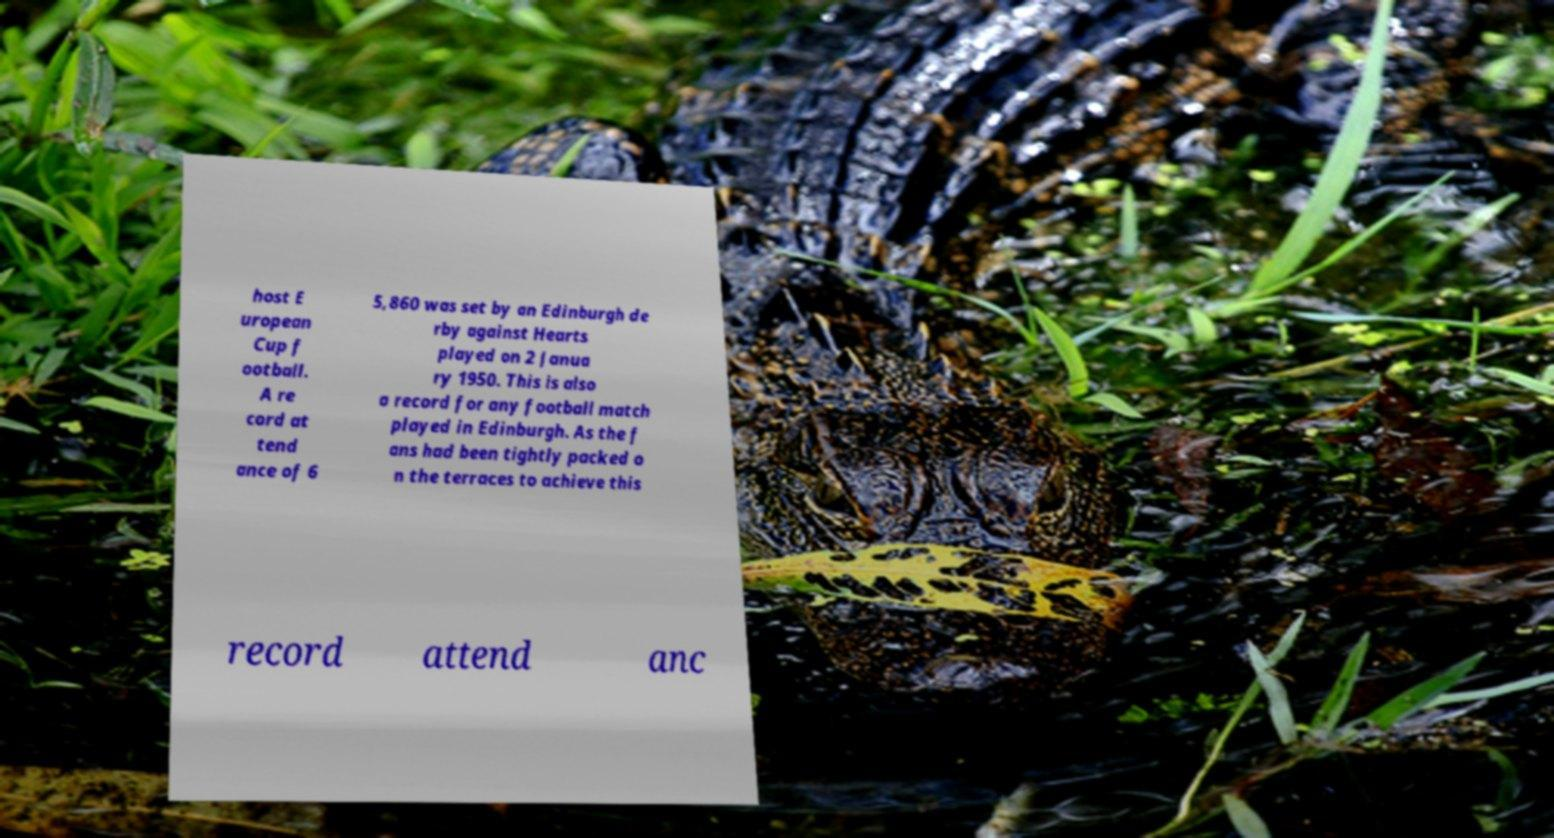For documentation purposes, I need the text within this image transcribed. Could you provide that? host E uropean Cup f ootball. A re cord at tend ance of 6 5,860 was set by an Edinburgh de rby against Hearts played on 2 Janua ry 1950. This is also a record for any football match played in Edinburgh. As the f ans had been tightly packed o n the terraces to achieve this record attend anc 